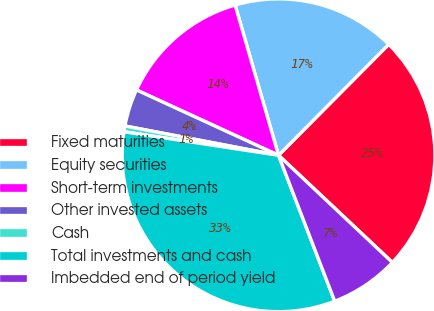Convert chart to OTSL. <chart><loc_0><loc_0><loc_500><loc_500><pie_chart><fcel>Fixed maturities<fcel>Equity securities<fcel>Short-term investments<fcel>Other invested assets<fcel>Cash<fcel>Total investments and cash<fcel>Imbedded end of period yield<nl><fcel>24.57%<fcel>16.92%<fcel>13.66%<fcel>3.86%<fcel>0.6%<fcel>33.25%<fcel>7.13%<nl></chart> 